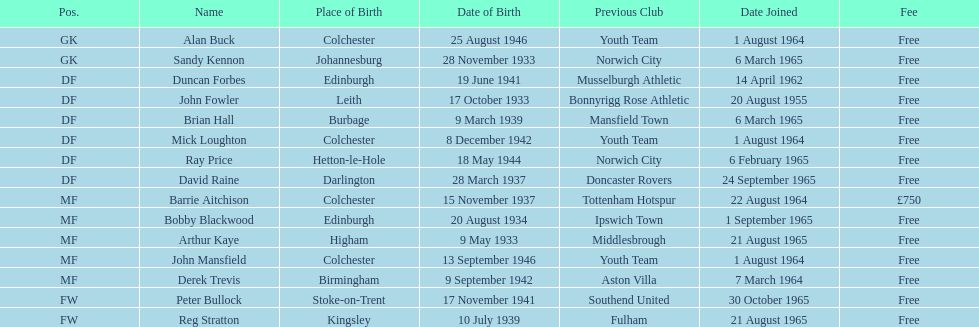What is the other expense noted, besides free? £750. 